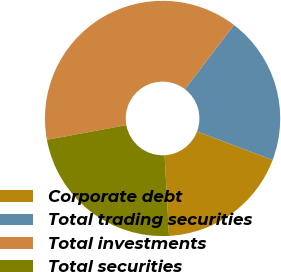<chart> <loc_0><loc_0><loc_500><loc_500><pie_chart><fcel>Corporate debt<fcel>Total trading securities<fcel>Total investments<fcel>Total securities<nl><fcel>18.38%<fcel>20.37%<fcel>38.28%<fcel>22.97%<nl></chart> 